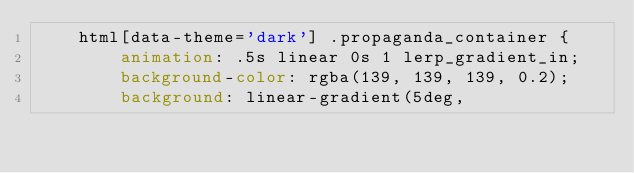<code> <loc_0><loc_0><loc_500><loc_500><_CSS_>    html[data-theme='dark'] .propaganda_container {
        animation: .5s linear 0s 1 lerp_gradient_in;
        background-color: rgba(139, 139, 139, 0.2);
        background: linear-gradient(5deg,             </code> 